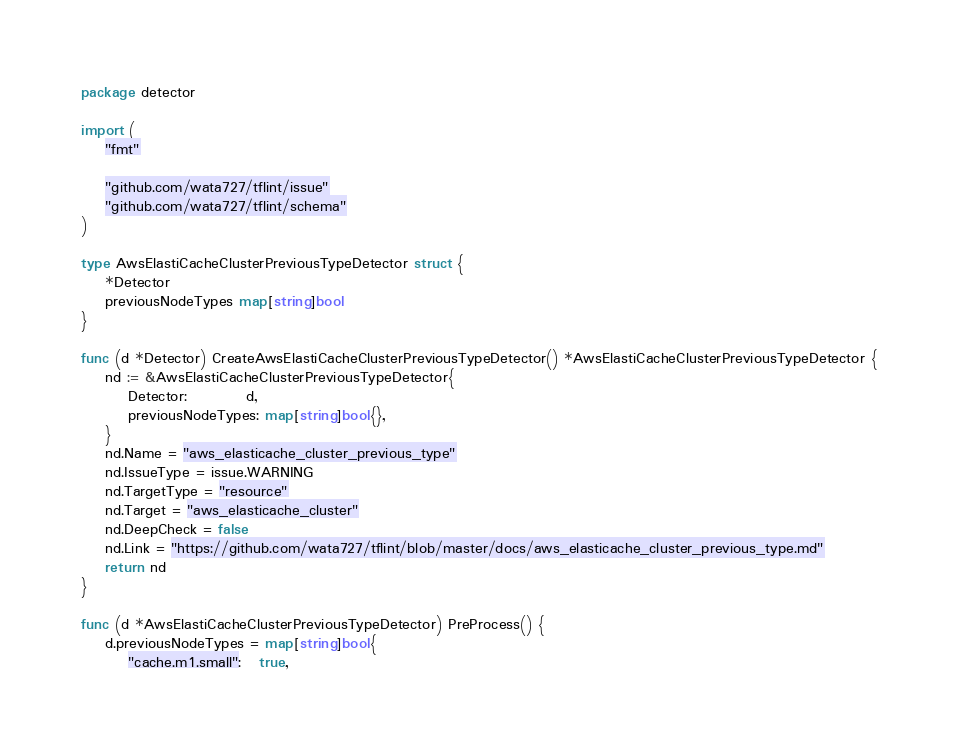Convert code to text. <code><loc_0><loc_0><loc_500><loc_500><_Go_>package detector

import (
	"fmt"

	"github.com/wata727/tflint/issue"
	"github.com/wata727/tflint/schema"
)

type AwsElastiCacheClusterPreviousTypeDetector struct {
	*Detector
	previousNodeTypes map[string]bool
}

func (d *Detector) CreateAwsElastiCacheClusterPreviousTypeDetector() *AwsElastiCacheClusterPreviousTypeDetector {
	nd := &AwsElastiCacheClusterPreviousTypeDetector{
		Detector:          d,
		previousNodeTypes: map[string]bool{},
	}
	nd.Name = "aws_elasticache_cluster_previous_type"
	nd.IssueType = issue.WARNING
	nd.TargetType = "resource"
	nd.Target = "aws_elasticache_cluster"
	nd.DeepCheck = false
	nd.Link = "https://github.com/wata727/tflint/blob/master/docs/aws_elasticache_cluster_previous_type.md"
	return nd
}

func (d *AwsElastiCacheClusterPreviousTypeDetector) PreProcess() {
	d.previousNodeTypes = map[string]bool{
		"cache.m1.small":   true,</code> 